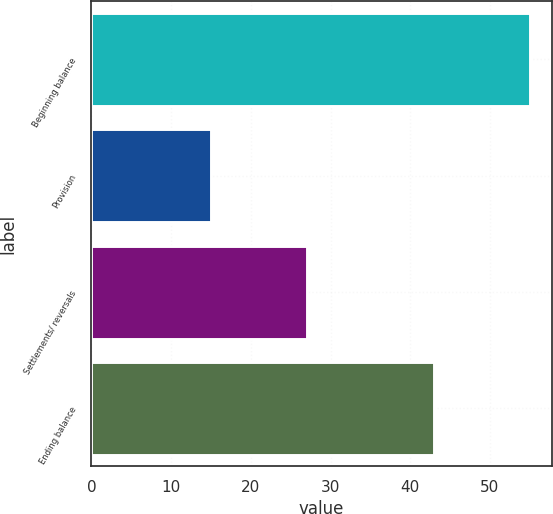<chart> <loc_0><loc_0><loc_500><loc_500><bar_chart><fcel>Beginning balance<fcel>Provision<fcel>Settlements/ reversals<fcel>Ending balance<nl><fcel>55<fcel>15<fcel>27<fcel>43<nl></chart> 